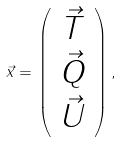<formula> <loc_0><loc_0><loc_500><loc_500>\vec { x } = \left ( \begin{array} { c } \vec { T } \\ \vec { Q } \\ \vec { U } \end{array} \right ) ,</formula> 